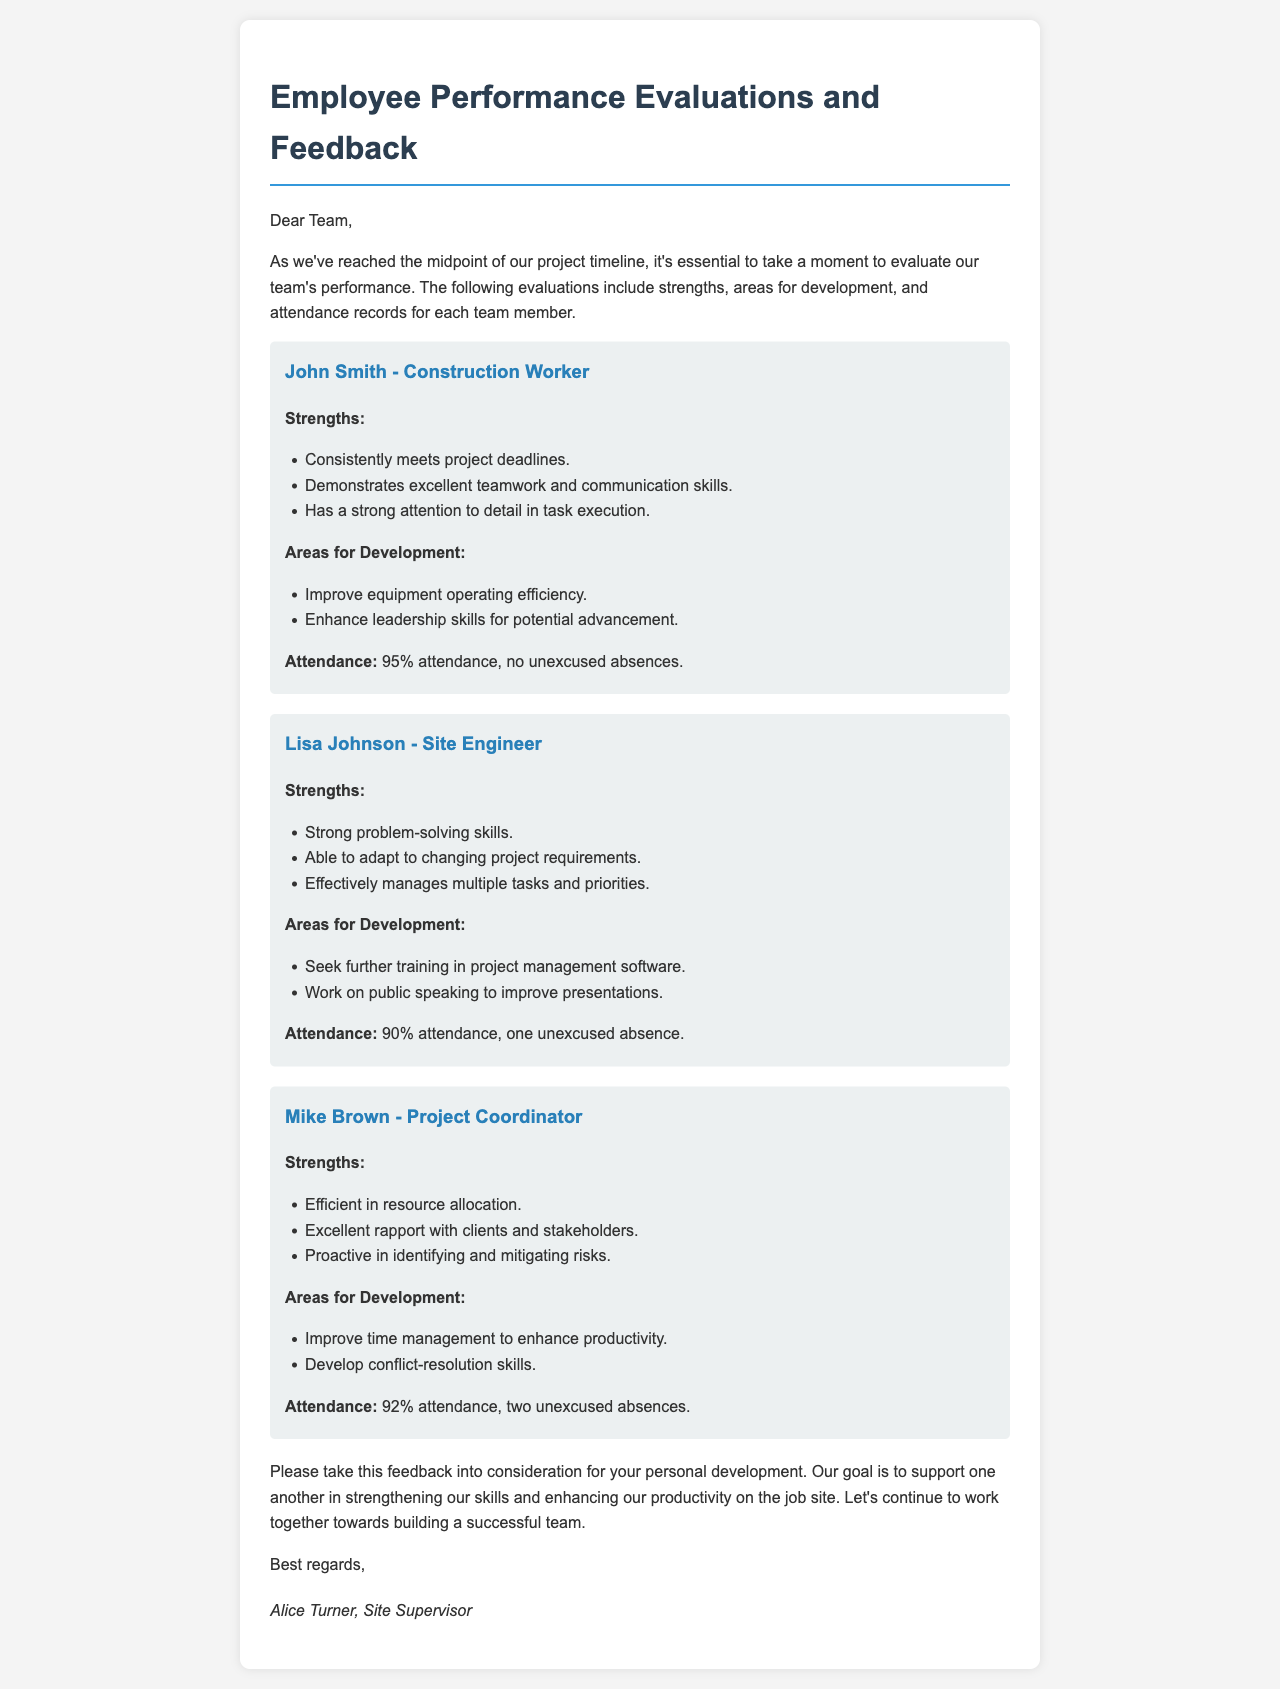What is the name of the site supervisor? The document includes a signature at the end, which indicates that Alice Turner is the site supervisor.
Answer: Alice Turner What is John Smith's job title? The job title for John Smith is stated at the beginning of his evaluation section.
Answer: Construction Worker What percentage of attendance did Lisa Johnson achieve? The attendance record for Lisa Johnson shows a percentage based on her presence during the evaluation period.
Answer: 90% Which employee has a strong attention to detail? John Smith's evaluation specifically lists strong attention to detail under his strengths.
Answer: John Smith How many unexcused absences does Mike Brown have? The attendance section for Mike Brown details the count of unexcused absences recorded during his evaluation.
Answer: Two unexcused absences What area of development is suggested for Lisa Johnson? One of Lisa Johnson's areas for development is seeking further training in a specific skill.
Answer: Project management software Which employee is encouraged to develop conflict-resolution skills? Mike Brown's evaluation mentions the need to develop conflict-resolution skills in his areas for development.
Answer: Mike Brown What is the overall goal stated at the end of the document? The conclusion of the document mentions the importance of supporting one another for a specific end goal.
Answer: Strengthening our skills and enhancing our productivity What strength is highlighted for Mike Brown? The strengths section mentions his efficiency in a particular role regarding resource management.
Answer: Efficient in resource allocation 